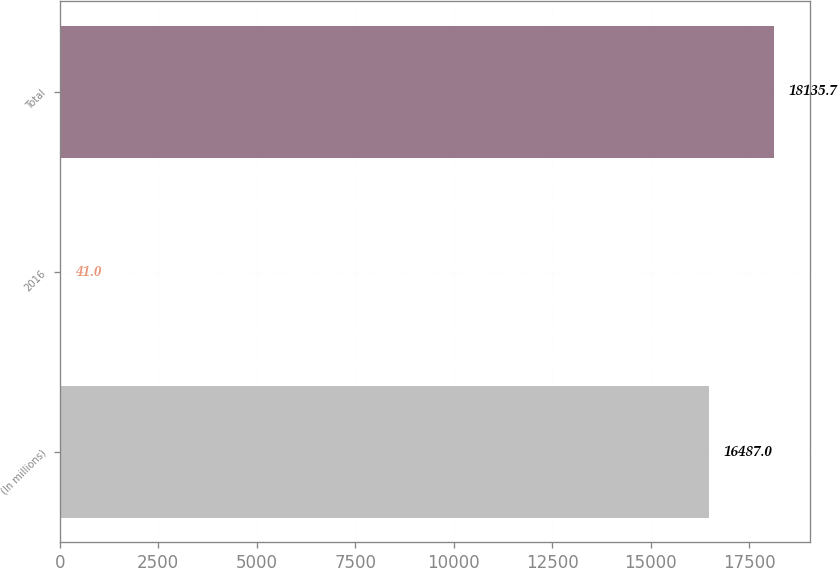Convert chart. <chart><loc_0><loc_0><loc_500><loc_500><bar_chart><fcel>(In millions)<fcel>2016<fcel>Total<nl><fcel>16487<fcel>41<fcel>18135.7<nl></chart> 